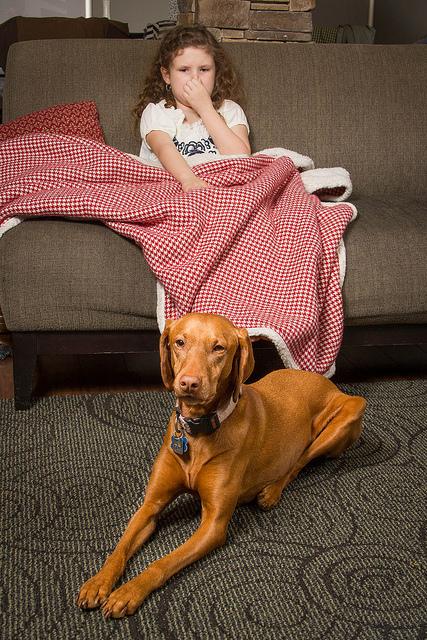What color is the child's blanket?
Give a very brief answer. Red. Is the dog wearing a collar?
Quick response, please. Yes. Do you think the dog smells?
Keep it brief. Yes. 